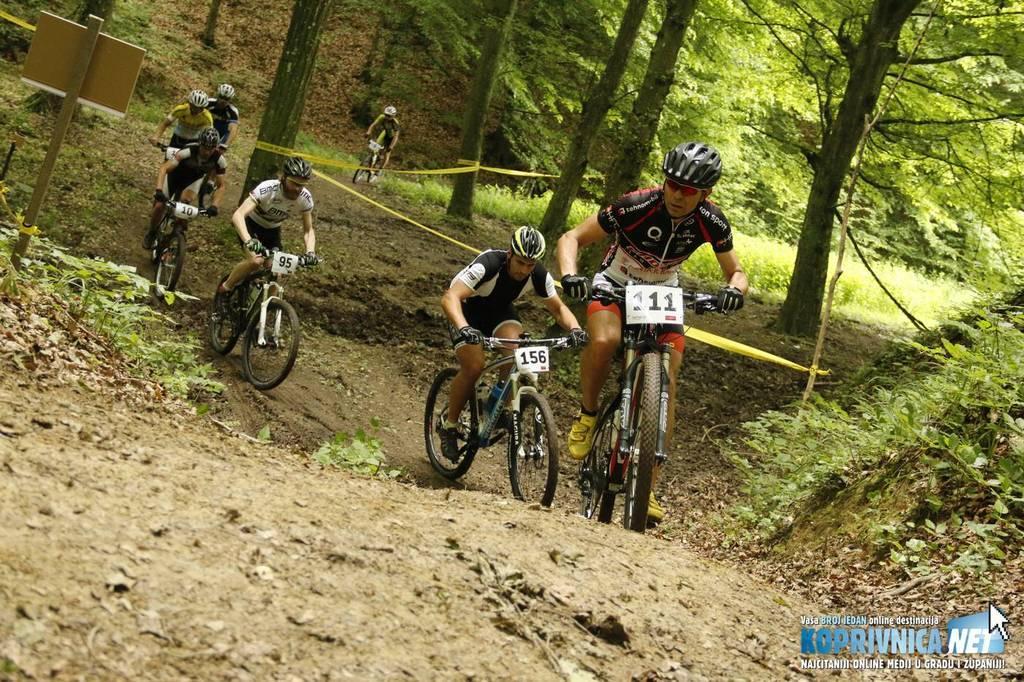Please provide a concise description of this image. In the picture there are people riding bicycles, they are wearing helmets, there are trees, there are creeps present. 